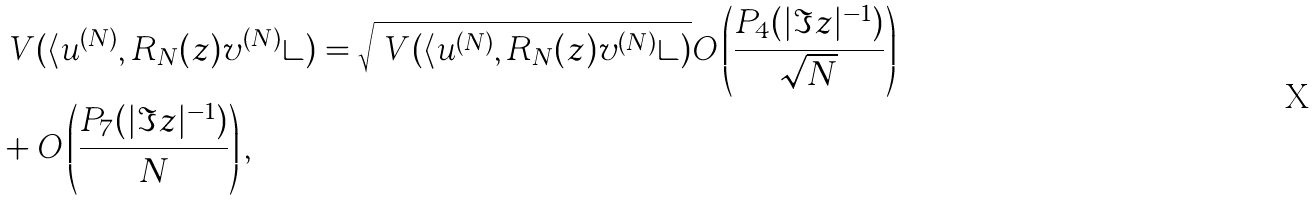<formula> <loc_0><loc_0><loc_500><loc_500>& \ V ( \langle u ^ { ( N ) } , R _ { N } ( z ) v ^ { ( N ) } \rangle ) = \sqrt { \ V ( \langle u ^ { ( N ) } , R _ { N } ( z ) v ^ { ( N ) } \rangle ) } O \left ( \frac { P _ { 4 } ( | \Im z | ^ { - 1 } ) } { \sqrt { N } } \right ) \\ & + O \left ( \frac { P _ { 7 } ( | \Im z | ^ { - 1 } ) } { N } \right ) ,</formula> 